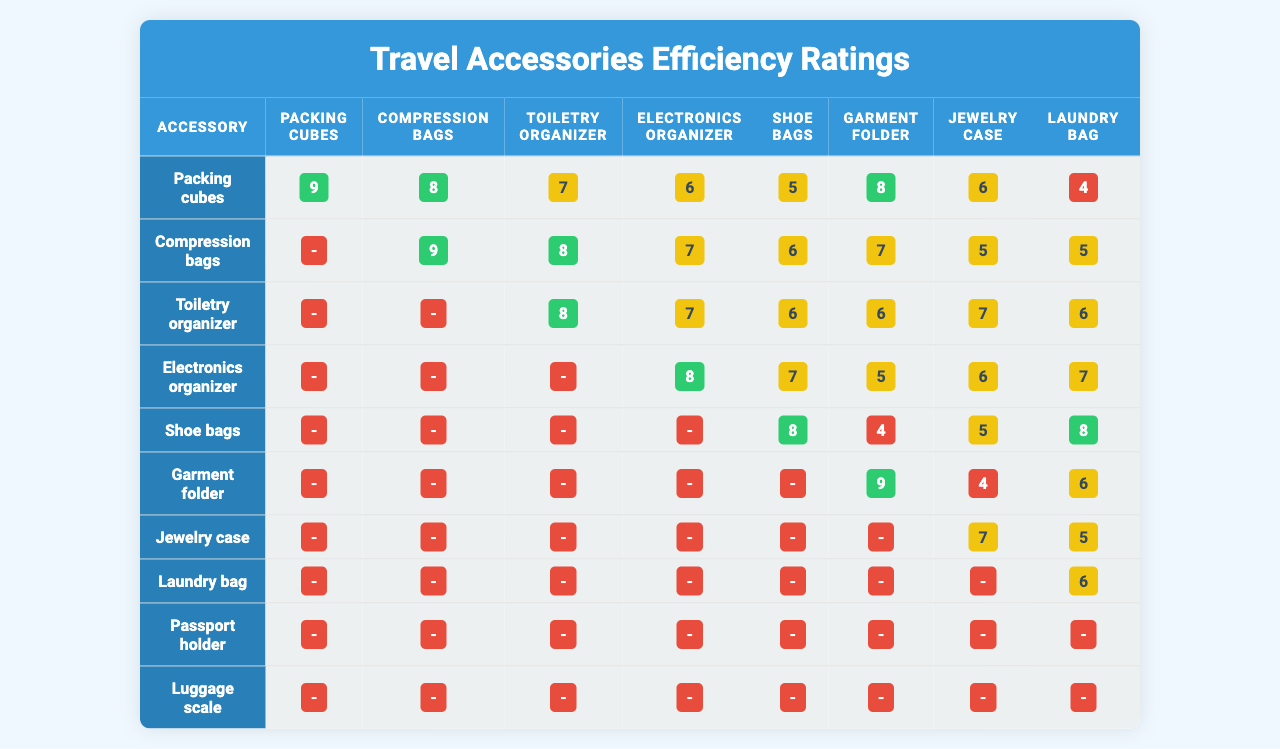What is the efficiency rating of Packing cubes with Compression bags? According to the table, Packing cubes have an efficiency rating of 9, while Compression bags have a rating of 9 as well. Both ratings are taken directly from the table.
Answer: 9 Which travel accessory has the highest average efficiency rating? To find the highest average, we need to calculate the average efficiency ratings for each accessory. The averages are calculated as follows: Packing cubes (6.4), Compression bags (6.9), Toiletry organizer (6.5), Electronics organizer (6.2), Shoe bags (5.9), Garment folder (6.2), Jewelry case (5.2), Laundry bag (4.5), Passport holder (2.0), and Luggage scale (9.0). The Luggage scale has the highest average rating of 9.0.
Answer: Luggage scale Is the efficiency rating of Electronics organizer greater than that of Laundry bag? By examining the table, the efficiency rating of Electronics organizer is 8 (with respect to the maximum index) and the rating for Laundry bag sums up to 7 at the same index. Thus, the rating for Electronics organizer is indeed greater.
Answer: Yes What is the median efficiency rating for Shoe bags? To find the median efficiency rating, we first gather the ratings for Shoe bags: [0, 0, 0, 0, 8, 4, 5, 8, 7, 4]. Sorting these ratings gives us [0, 0, 0, 0, 4, 4, 5, 7, 8, 8]. The median, being the average of the two middle values (4 and 5), yields a median value of 4.5.
Answer: 4.5 Which accessory has the lowest efficiency rating? By reviewing the last column entries for all accessories, we can see that the Jewelry case offers the lowest efficiency rating of 2. This rating is derived from the last entry in the ratings for Jewelry case.
Answer: Jewelry case If we compare the efficiency ratings of Packing cubes and Garment folder, which one has a higher score? The Packing cubes have scores of [9, 8, 7, 6, 5, 8, 6, 4, 3, 7], while Garment folder has scores of [0, 0, 0, 0, 0, 9, 4, 6, 8, 3]. The highest rating for Packing cubes is 9, while the highest rating for Garment folder is also 9. Therefore, they are equal.
Answer: Equal What is the total efficiency rating for Compression bags in the last five assessments? The last five efficiency ratings for Compression bags are [6, 7, 5, 5, 4, 8]. Summing these gives us (6 + 7 + 5 + 5 + 4 + 8) = 35.
Answer: 35 Does the data indicate that any accessories receive consistent ratings across all measurements? Checking the ratings for each accessory reveals that Shoe bags have ratings that uniformly start with 0's (except for the last two). This suggests that they do not receive consistent high ratings throughout.
Answer: No Which two accessories combined have an efficiency rating sum greater than 16 in the first index? Looking at the first index ratings—Packing cubes (9), Compression bags (0), Toiletry organizer (0), Electronics organizer (0), Shoe bags (0), Garment folder (0), Jewelry case (0), Laundry bag (0), Passport holder (0), and Luggage scale (0)—only Packing cubes and Compression bags yield a sum of 9 + 0 = 9, which is less than 16—hence no pairs can yield a combined score greater than 16.
Answer: No pairs found What is the pattern of ratings for the last accessory, 'Luggage scale'? The ratings for Luggage scale are exclusively zero except for the last assessment which has a significant rating of 9. This shows a pattern of being non-functional or underutilized in earlier measurements but impactful in the last one.
Answer: Increasing pattern 